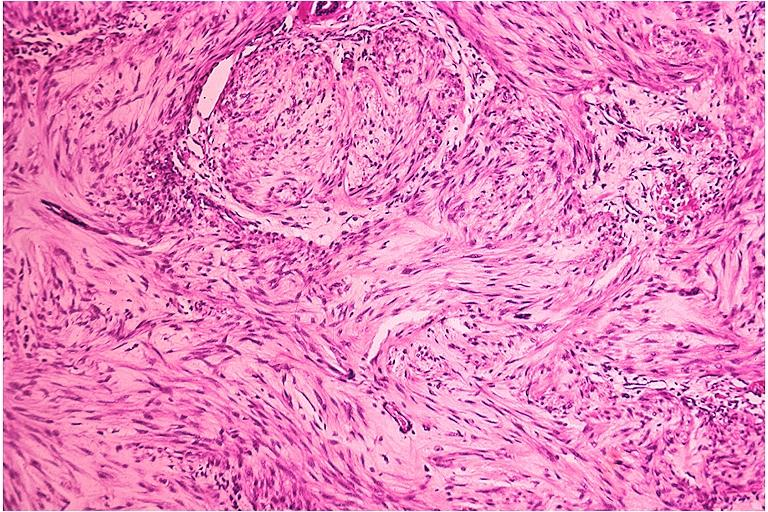s supernumerary digits present?
Answer the question using a single word or phrase. No 